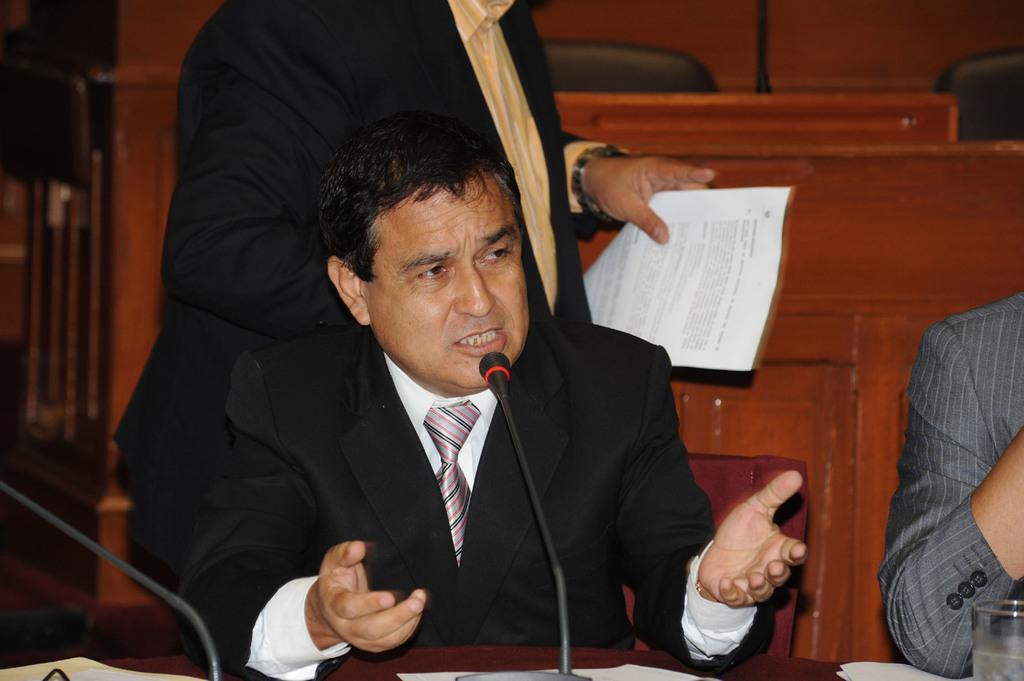Can you describe this image briefly? In the foreground of the picture there is a table, on the table there are microphones. In the center there is a man in black suit talking. To the right there is another person sitting. In the background there is a man standing and holding papers. In the background there are benches and seats. 